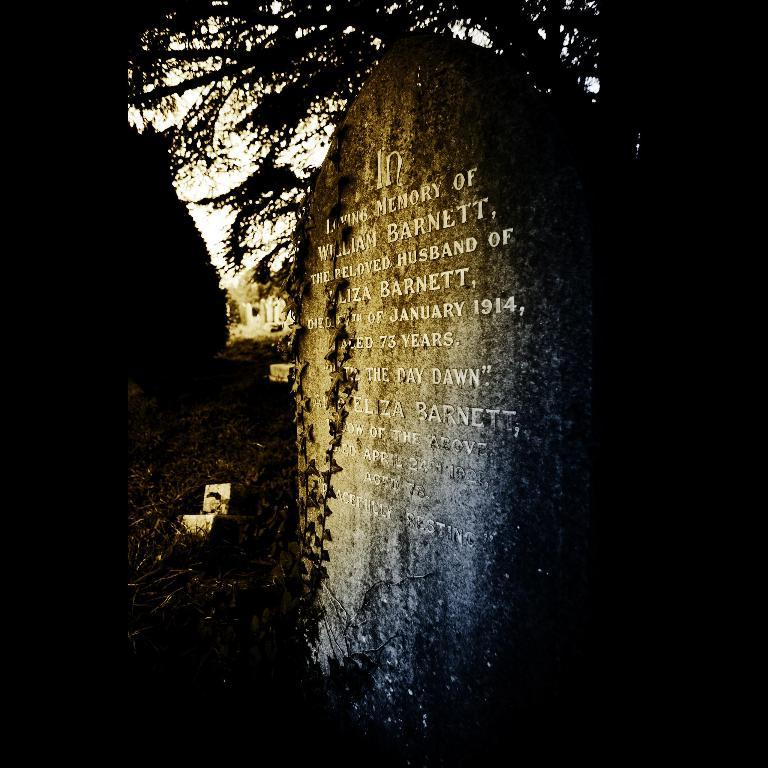What is the main object in the image? There is a stone in the image. What is written or depicted on the stone? There is text on the stone. What can be seen in the background of the image? There is a tree behind the stone. How often does the stone require a haircut in the image? Stones do not require haircuts, as they are inanimate objects and do not have hair. 